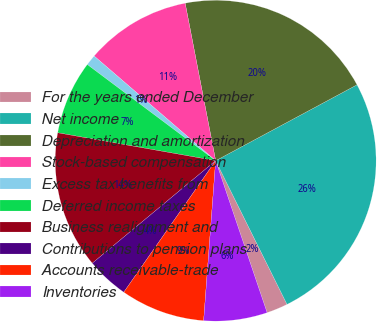Convert chart. <chart><loc_0><loc_0><loc_500><loc_500><pie_chart><fcel>For the years ended December<fcel>Net income<fcel>Depreciation and amortization<fcel>Stock-based compensation<fcel>Excess tax benefits from<fcel>Deferred income taxes<fcel>Business realignment and<fcel>Contributions to pension plans<fcel>Accounts receivable-trade<fcel>Inventories<nl><fcel>2.14%<fcel>25.51%<fcel>20.2%<fcel>10.64%<fcel>1.08%<fcel>7.45%<fcel>13.82%<fcel>4.26%<fcel>8.51%<fcel>6.39%<nl></chart> 